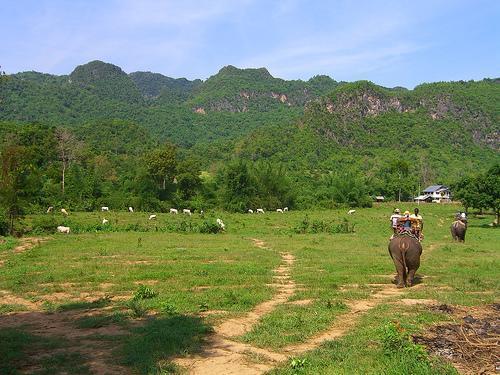How many elephants are visible?
Give a very brief answer. 2. 